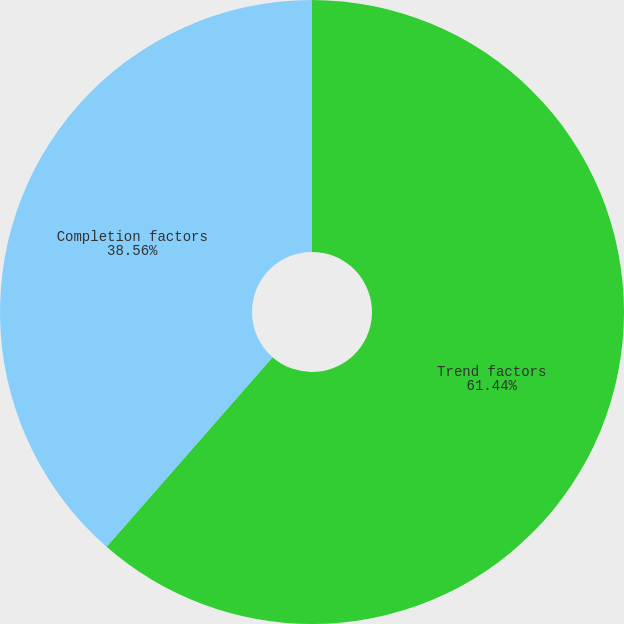<chart> <loc_0><loc_0><loc_500><loc_500><pie_chart><fcel>Trend factors<fcel>Completion factors<nl><fcel>61.44%<fcel>38.56%<nl></chart> 